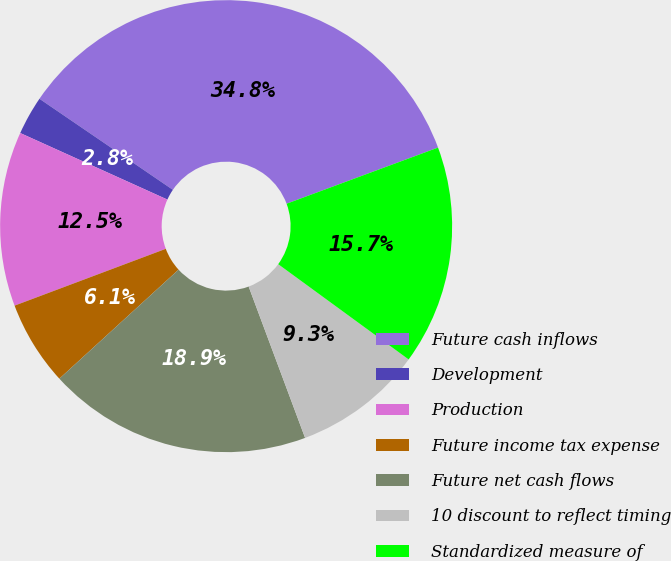Convert chart. <chart><loc_0><loc_0><loc_500><loc_500><pie_chart><fcel>Future cash inflows<fcel>Development<fcel>Production<fcel>Future income tax expense<fcel>Future net cash flows<fcel>10 discount to reflect timing<fcel>Standardized measure of<nl><fcel>34.82%<fcel>2.77%<fcel>12.48%<fcel>6.07%<fcel>18.89%<fcel>9.28%<fcel>15.69%<nl></chart> 